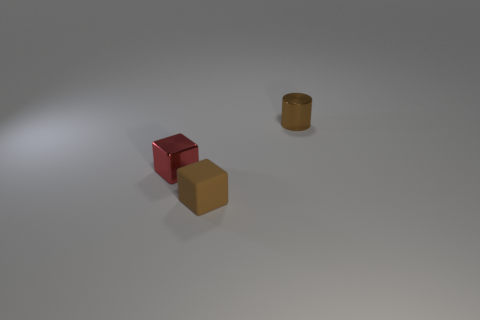The tiny matte object has what color?
Your answer should be compact. Brown. What number of big objects are either cylinders or red metal objects?
Keep it short and to the point. 0. Is the size of the brown object on the left side of the tiny metal cylinder the same as the object that is behind the shiny block?
Ensure brevity in your answer.  Yes. The metal thing that is the same shape as the brown matte object is what size?
Provide a succinct answer. Small. Are there more red objects behind the metallic cylinder than tiny cylinders in front of the brown matte object?
Your answer should be very brief. No. What is the material of the tiny object that is both behind the brown matte block and in front of the shiny cylinder?
Offer a terse response. Metal. What is the color of the other thing that is the same shape as the matte object?
Offer a terse response. Red. What is the size of the brown block?
Your answer should be very brief. Small. What color is the tiny metal thing that is right of the metallic thing in front of the brown cylinder?
Your answer should be compact. Brown. How many tiny brown objects are behind the brown block and to the left of the shiny cylinder?
Keep it short and to the point. 0. 